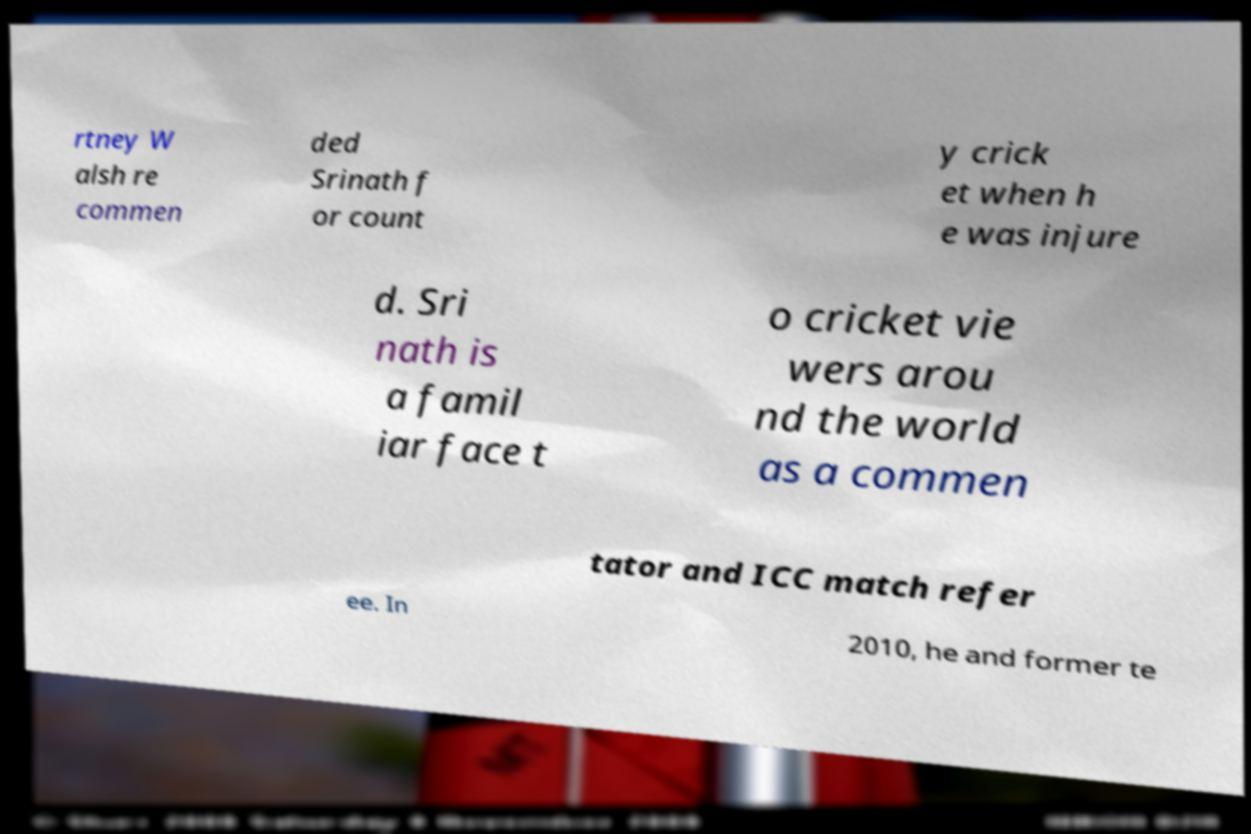What messages or text are displayed in this image? I need them in a readable, typed format. rtney W alsh re commen ded Srinath f or count y crick et when h e was injure d. Sri nath is a famil iar face t o cricket vie wers arou nd the world as a commen tator and ICC match refer ee. In 2010, he and former te 